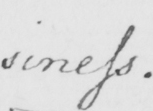Can you tell me what this handwritten text says? : siness . 